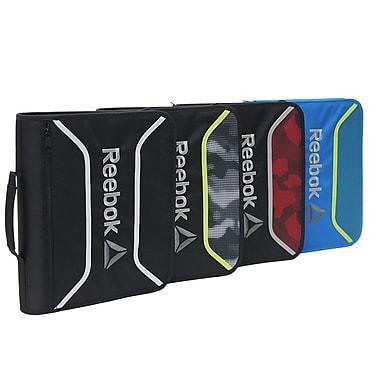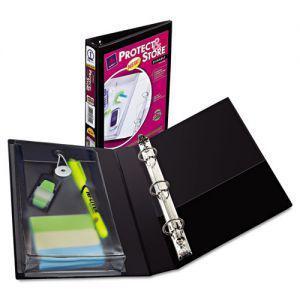The first image is the image on the left, the second image is the image on the right. Considering the images on both sides, is "Four versions of a binder are standing in a row and overlapping each other." valid? Answer yes or no. Yes. The first image is the image on the left, the second image is the image on the right. Evaluate the accuracy of this statement regarding the images: "The right image contains at least one open binder and one closed binder.". Is it true? Answer yes or no. Yes. 